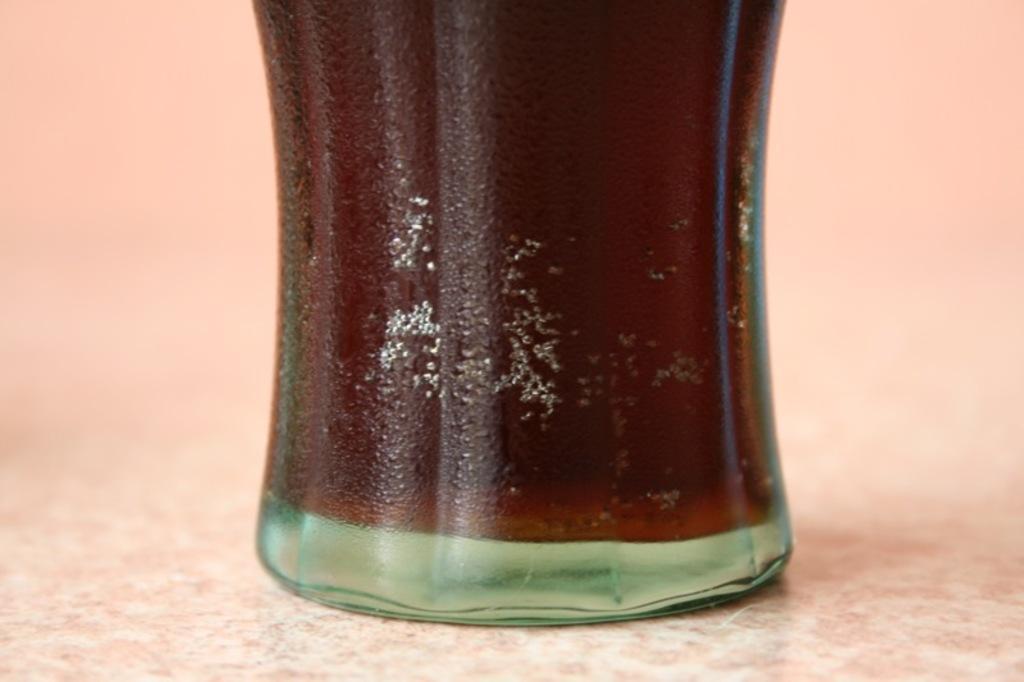Can you describe this image briefly? In this image we can see a bottle placed on the surface. 